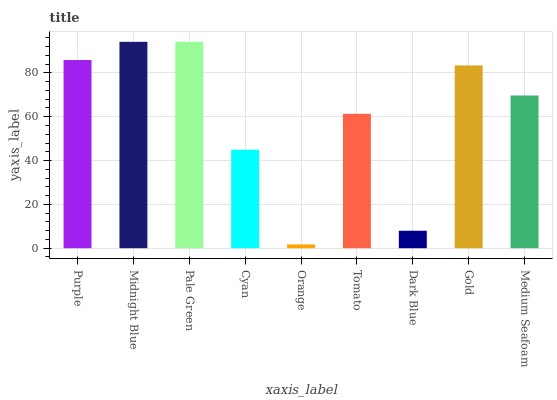Is Orange the minimum?
Answer yes or no. Yes. Is Pale Green the maximum?
Answer yes or no. Yes. Is Midnight Blue the minimum?
Answer yes or no. No. Is Midnight Blue the maximum?
Answer yes or no. No. Is Midnight Blue greater than Purple?
Answer yes or no. Yes. Is Purple less than Midnight Blue?
Answer yes or no. Yes. Is Purple greater than Midnight Blue?
Answer yes or no. No. Is Midnight Blue less than Purple?
Answer yes or no. No. Is Medium Seafoam the high median?
Answer yes or no. Yes. Is Medium Seafoam the low median?
Answer yes or no. Yes. Is Pale Green the high median?
Answer yes or no. No. Is Cyan the low median?
Answer yes or no. No. 